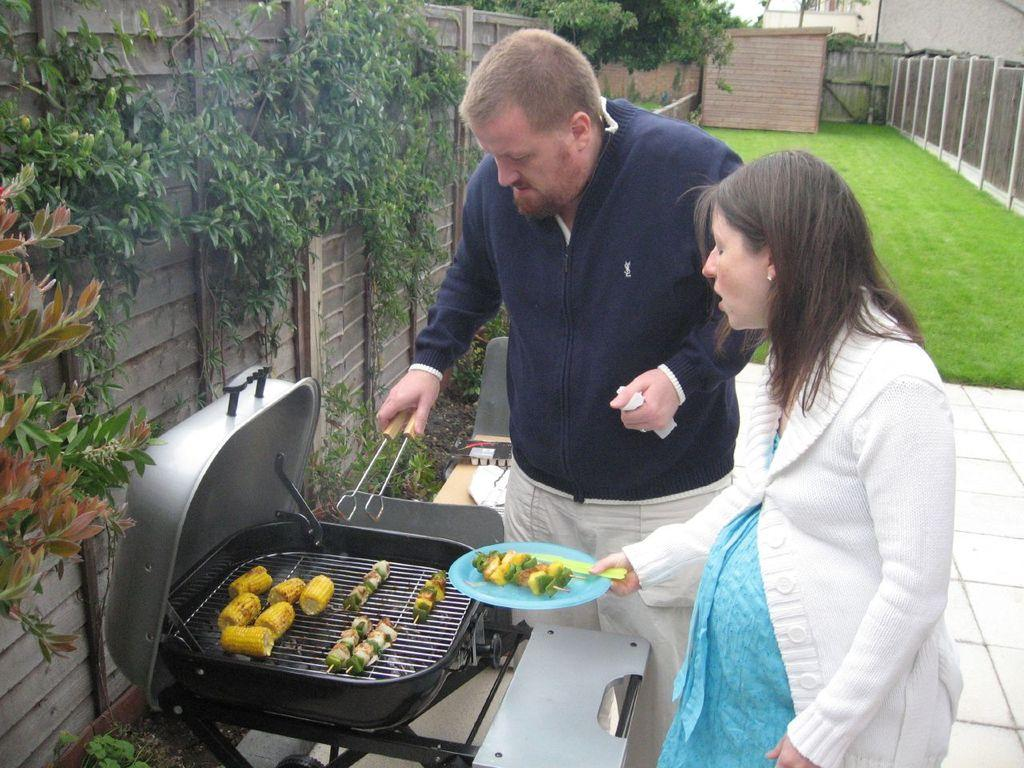What is being cooked on the barbecue in the image? There is food on the barbecue in the image. What is the man holding in the image? The man is holding tongs in the image. What is the woman holding in the image? The woman is holding a serving plate in the image. What can be seen in the background of the image? There is ground, walls, creepers, and trees visible in the background of the image. What type of surface is under the people in the image? There is a floor in the background of the image. What type of insurance policy is the man discussing with the woman in the image? There is no indication of a discussion about insurance in the image; the man is holding tongs and the woman is holding a serving plate. What type of drum can be seen in the image? There is no drum present in the image. 